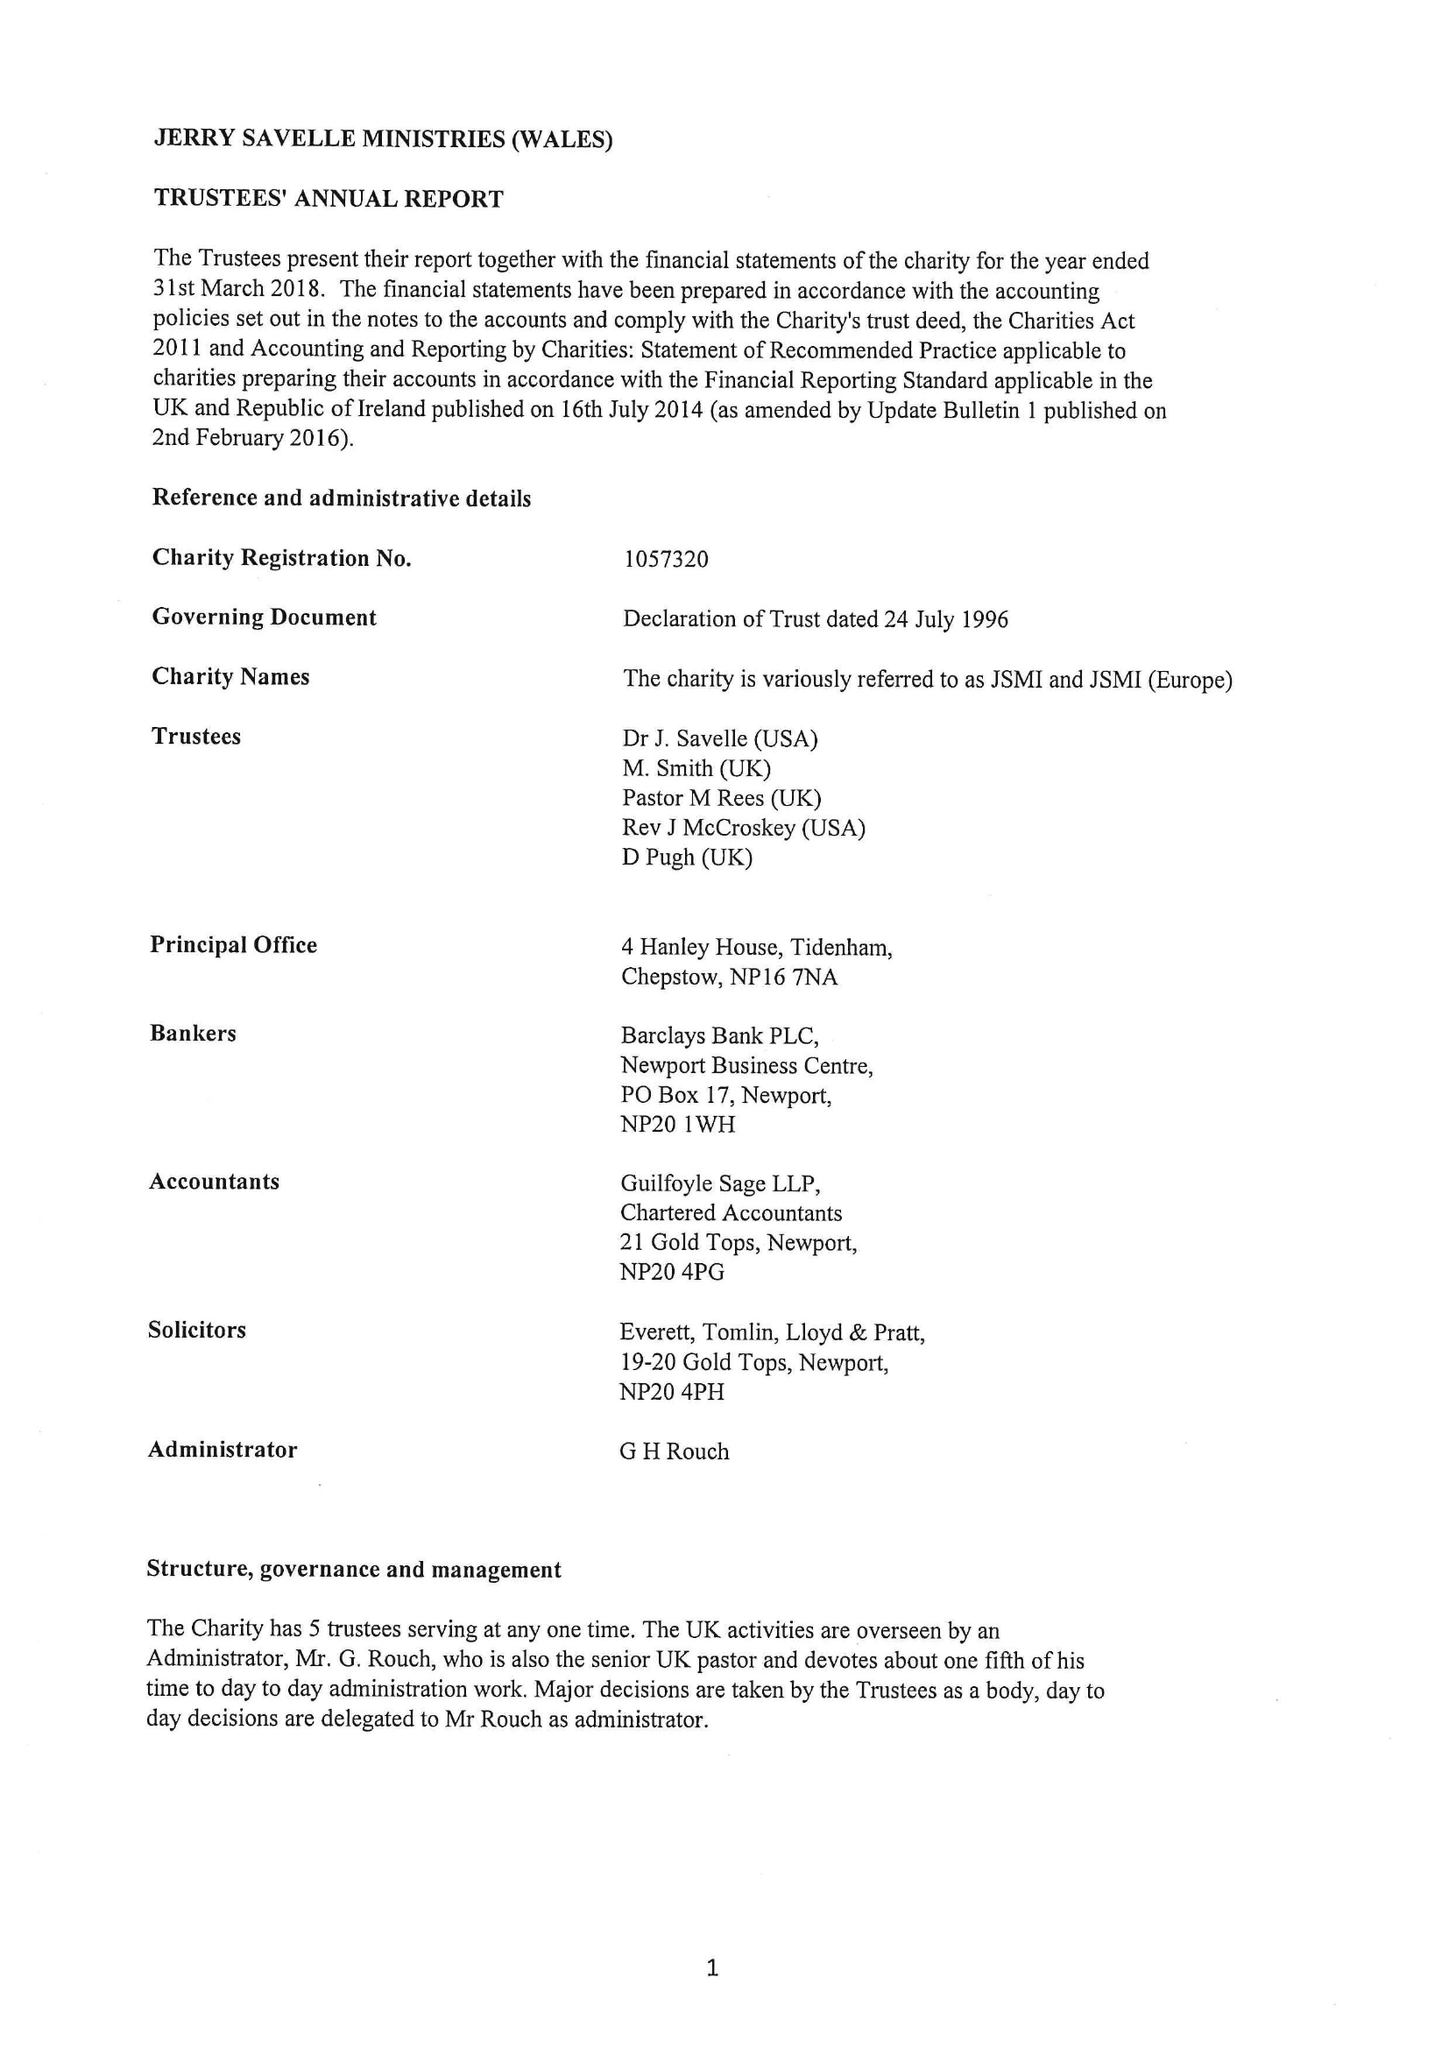What is the value for the income_annually_in_british_pounds?
Answer the question using a single word or phrase. 228778.00 